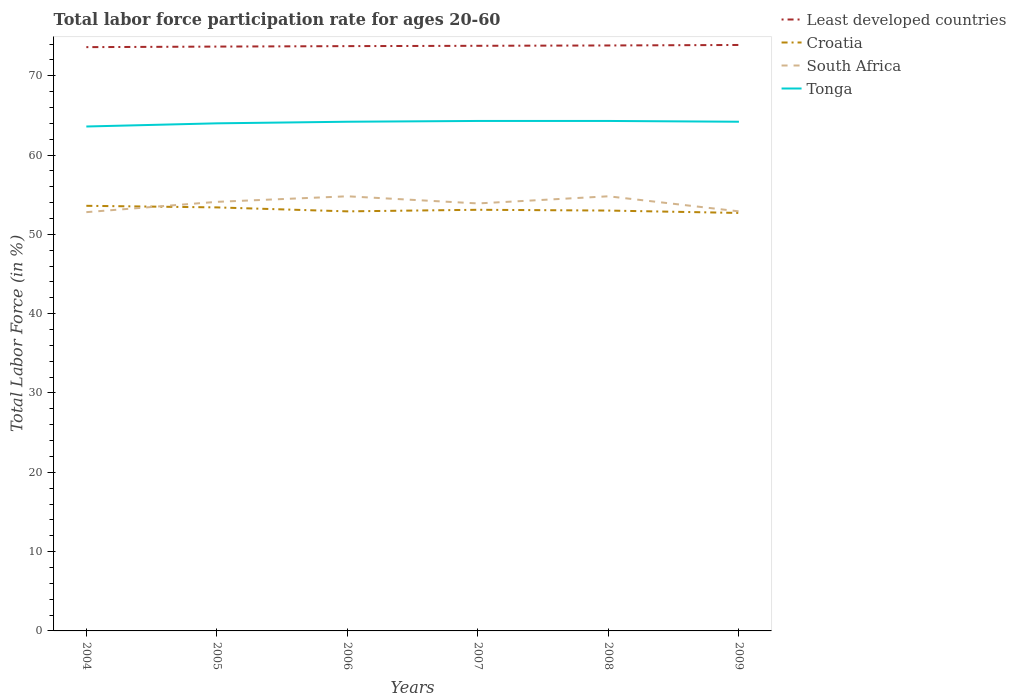How many different coloured lines are there?
Provide a succinct answer. 4. Does the line corresponding to Croatia intersect with the line corresponding to Tonga?
Provide a succinct answer. No. Is the number of lines equal to the number of legend labels?
Keep it short and to the point. Yes. Across all years, what is the maximum labor force participation rate in Croatia?
Ensure brevity in your answer.  52.7. In which year was the labor force participation rate in South Africa maximum?
Offer a very short reply. 2004. What is the total labor force participation rate in Least developed countries in the graph?
Your answer should be very brief. -0.2. What is the difference between the highest and the lowest labor force participation rate in Least developed countries?
Make the answer very short. 3. Is the labor force participation rate in Croatia strictly greater than the labor force participation rate in Least developed countries over the years?
Your response must be concise. Yes. How many lines are there?
Keep it short and to the point. 4. Does the graph contain grids?
Offer a terse response. No. What is the title of the graph?
Make the answer very short. Total labor force participation rate for ages 20-60. Does "Caribbean small states" appear as one of the legend labels in the graph?
Offer a very short reply. No. What is the label or title of the X-axis?
Keep it short and to the point. Years. What is the Total Labor Force (in %) of Least developed countries in 2004?
Give a very brief answer. 73.61. What is the Total Labor Force (in %) of Croatia in 2004?
Provide a short and direct response. 53.6. What is the Total Labor Force (in %) of South Africa in 2004?
Offer a very short reply. 52.8. What is the Total Labor Force (in %) of Tonga in 2004?
Give a very brief answer. 63.6. What is the Total Labor Force (in %) in Least developed countries in 2005?
Offer a terse response. 73.68. What is the Total Labor Force (in %) in Croatia in 2005?
Your response must be concise. 53.4. What is the Total Labor Force (in %) of South Africa in 2005?
Your answer should be compact. 54.1. What is the Total Labor Force (in %) in Least developed countries in 2006?
Your answer should be very brief. 73.73. What is the Total Labor Force (in %) of Croatia in 2006?
Your answer should be compact. 52.9. What is the Total Labor Force (in %) of South Africa in 2006?
Give a very brief answer. 54.8. What is the Total Labor Force (in %) in Tonga in 2006?
Keep it short and to the point. 64.2. What is the Total Labor Force (in %) in Least developed countries in 2007?
Offer a very short reply. 73.77. What is the Total Labor Force (in %) in Croatia in 2007?
Your response must be concise. 53.1. What is the Total Labor Force (in %) in South Africa in 2007?
Your response must be concise. 53.9. What is the Total Labor Force (in %) in Tonga in 2007?
Keep it short and to the point. 64.3. What is the Total Labor Force (in %) of Least developed countries in 2008?
Your answer should be very brief. 73.82. What is the Total Labor Force (in %) in South Africa in 2008?
Your answer should be very brief. 54.8. What is the Total Labor Force (in %) of Tonga in 2008?
Ensure brevity in your answer.  64.3. What is the Total Labor Force (in %) of Least developed countries in 2009?
Keep it short and to the point. 73.88. What is the Total Labor Force (in %) of Croatia in 2009?
Your response must be concise. 52.7. What is the Total Labor Force (in %) of South Africa in 2009?
Offer a terse response. 52.9. What is the Total Labor Force (in %) in Tonga in 2009?
Keep it short and to the point. 64.2. Across all years, what is the maximum Total Labor Force (in %) of Least developed countries?
Your answer should be very brief. 73.88. Across all years, what is the maximum Total Labor Force (in %) in Croatia?
Provide a short and direct response. 53.6. Across all years, what is the maximum Total Labor Force (in %) in South Africa?
Offer a terse response. 54.8. Across all years, what is the maximum Total Labor Force (in %) of Tonga?
Ensure brevity in your answer.  64.3. Across all years, what is the minimum Total Labor Force (in %) of Least developed countries?
Your answer should be very brief. 73.61. Across all years, what is the minimum Total Labor Force (in %) of Croatia?
Provide a succinct answer. 52.7. Across all years, what is the minimum Total Labor Force (in %) in South Africa?
Ensure brevity in your answer.  52.8. Across all years, what is the minimum Total Labor Force (in %) in Tonga?
Offer a very short reply. 63.6. What is the total Total Labor Force (in %) of Least developed countries in the graph?
Offer a terse response. 442.49. What is the total Total Labor Force (in %) of Croatia in the graph?
Ensure brevity in your answer.  318.7. What is the total Total Labor Force (in %) in South Africa in the graph?
Ensure brevity in your answer.  323.3. What is the total Total Labor Force (in %) in Tonga in the graph?
Provide a succinct answer. 384.6. What is the difference between the Total Labor Force (in %) of Least developed countries in 2004 and that in 2005?
Your answer should be very brief. -0.07. What is the difference between the Total Labor Force (in %) in South Africa in 2004 and that in 2005?
Give a very brief answer. -1.3. What is the difference between the Total Labor Force (in %) of Tonga in 2004 and that in 2005?
Give a very brief answer. -0.4. What is the difference between the Total Labor Force (in %) of Least developed countries in 2004 and that in 2006?
Keep it short and to the point. -0.13. What is the difference between the Total Labor Force (in %) of South Africa in 2004 and that in 2006?
Ensure brevity in your answer.  -2. What is the difference between the Total Labor Force (in %) in Tonga in 2004 and that in 2006?
Ensure brevity in your answer.  -0.6. What is the difference between the Total Labor Force (in %) of Least developed countries in 2004 and that in 2007?
Provide a short and direct response. -0.17. What is the difference between the Total Labor Force (in %) in Croatia in 2004 and that in 2007?
Your answer should be very brief. 0.5. What is the difference between the Total Labor Force (in %) of South Africa in 2004 and that in 2007?
Offer a terse response. -1.1. What is the difference between the Total Labor Force (in %) in Least developed countries in 2004 and that in 2008?
Your answer should be very brief. -0.21. What is the difference between the Total Labor Force (in %) in Least developed countries in 2004 and that in 2009?
Your response must be concise. -0.27. What is the difference between the Total Labor Force (in %) in Croatia in 2004 and that in 2009?
Offer a very short reply. 0.9. What is the difference between the Total Labor Force (in %) of South Africa in 2004 and that in 2009?
Provide a succinct answer. -0.1. What is the difference between the Total Labor Force (in %) of Tonga in 2004 and that in 2009?
Provide a succinct answer. -0.6. What is the difference between the Total Labor Force (in %) of Least developed countries in 2005 and that in 2006?
Provide a succinct answer. -0.06. What is the difference between the Total Labor Force (in %) in South Africa in 2005 and that in 2006?
Provide a short and direct response. -0.7. What is the difference between the Total Labor Force (in %) of Tonga in 2005 and that in 2006?
Ensure brevity in your answer.  -0.2. What is the difference between the Total Labor Force (in %) in Least developed countries in 2005 and that in 2007?
Your answer should be very brief. -0.1. What is the difference between the Total Labor Force (in %) in South Africa in 2005 and that in 2007?
Offer a terse response. 0.2. What is the difference between the Total Labor Force (in %) of Tonga in 2005 and that in 2007?
Ensure brevity in your answer.  -0.3. What is the difference between the Total Labor Force (in %) in Least developed countries in 2005 and that in 2008?
Make the answer very short. -0.14. What is the difference between the Total Labor Force (in %) of Croatia in 2005 and that in 2008?
Give a very brief answer. 0.4. What is the difference between the Total Labor Force (in %) in Least developed countries in 2005 and that in 2009?
Ensure brevity in your answer.  -0.2. What is the difference between the Total Labor Force (in %) of Croatia in 2005 and that in 2009?
Your answer should be compact. 0.7. What is the difference between the Total Labor Force (in %) in South Africa in 2005 and that in 2009?
Your answer should be compact. 1.2. What is the difference between the Total Labor Force (in %) in Least developed countries in 2006 and that in 2007?
Give a very brief answer. -0.04. What is the difference between the Total Labor Force (in %) of Tonga in 2006 and that in 2007?
Offer a terse response. -0.1. What is the difference between the Total Labor Force (in %) in Least developed countries in 2006 and that in 2008?
Give a very brief answer. -0.08. What is the difference between the Total Labor Force (in %) of South Africa in 2006 and that in 2008?
Your answer should be very brief. 0. What is the difference between the Total Labor Force (in %) in Tonga in 2006 and that in 2008?
Give a very brief answer. -0.1. What is the difference between the Total Labor Force (in %) in Least developed countries in 2006 and that in 2009?
Your response must be concise. -0.15. What is the difference between the Total Labor Force (in %) of Least developed countries in 2007 and that in 2008?
Your answer should be compact. -0.04. What is the difference between the Total Labor Force (in %) in Croatia in 2007 and that in 2008?
Your answer should be compact. 0.1. What is the difference between the Total Labor Force (in %) of Least developed countries in 2007 and that in 2009?
Ensure brevity in your answer.  -0.1. What is the difference between the Total Labor Force (in %) in Croatia in 2007 and that in 2009?
Keep it short and to the point. 0.4. What is the difference between the Total Labor Force (in %) in South Africa in 2007 and that in 2009?
Keep it short and to the point. 1. What is the difference between the Total Labor Force (in %) of Tonga in 2007 and that in 2009?
Offer a very short reply. 0.1. What is the difference between the Total Labor Force (in %) of Least developed countries in 2008 and that in 2009?
Ensure brevity in your answer.  -0.06. What is the difference between the Total Labor Force (in %) in Croatia in 2008 and that in 2009?
Give a very brief answer. 0.3. What is the difference between the Total Labor Force (in %) of South Africa in 2008 and that in 2009?
Give a very brief answer. 1.9. What is the difference between the Total Labor Force (in %) in Tonga in 2008 and that in 2009?
Your answer should be compact. 0.1. What is the difference between the Total Labor Force (in %) in Least developed countries in 2004 and the Total Labor Force (in %) in Croatia in 2005?
Your answer should be very brief. 20.21. What is the difference between the Total Labor Force (in %) of Least developed countries in 2004 and the Total Labor Force (in %) of South Africa in 2005?
Your answer should be compact. 19.51. What is the difference between the Total Labor Force (in %) of Least developed countries in 2004 and the Total Labor Force (in %) of Tonga in 2005?
Your answer should be very brief. 9.61. What is the difference between the Total Labor Force (in %) of Croatia in 2004 and the Total Labor Force (in %) of Tonga in 2005?
Your response must be concise. -10.4. What is the difference between the Total Labor Force (in %) of South Africa in 2004 and the Total Labor Force (in %) of Tonga in 2005?
Offer a very short reply. -11.2. What is the difference between the Total Labor Force (in %) of Least developed countries in 2004 and the Total Labor Force (in %) of Croatia in 2006?
Your response must be concise. 20.71. What is the difference between the Total Labor Force (in %) of Least developed countries in 2004 and the Total Labor Force (in %) of South Africa in 2006?
Make the answer very short. 18.81. What is the difference between the Total Labor Force (in %) in Least developed countries in 2004 and the Total Labor Force (in %) in Tonga in 2006?
Give a very brief answer. 9.41. What is the difference between the Total Labor Force (in %) in Croatia in 2004 and the Total Labor Force (in %) in Tonga in 2006?
Give a very brief answer. -10.6. What is the difference between the Total Labor Force (in %) in Least developed countries in 2004 and the Total Labor Force (in %) in Croatia in 2007?
Offer a very short reply. 20.51. What is the difference between the Total Labor Force (in %) of Least developed countries in 2004 and the Total Labor Force (in %) of South Africa in 2007?
Provide a short and direct response. 19.71. What is the difference between the Total Labor Force (in %) in Least developed countries in 2004 and the Total Labor Force (in %) in Tonga in 2007?
Give a very brief answer. 9.31. What is the difference between the Total Labor Force (in %) in Croatia in 2004 and the Total Labor Force (in %) in South Africa in 2007?
Give a very brief answer. -0.3. What is the difference between the Total Labor Force (in %) in Croatia in 2004 and the Total Labor Force (in %) in Tonga in 2007?
Give a very brief answer. -10.7. What is the difference between the Total Labor Force (in %) in Least developed countries in 2004 and the Total Labor Force (in %) in Croatia in 2008?
Your response must be concise. 20.61. What is the difference between the Total Labor Force (in %) of Least developed countries in 2004 and the Total Labor Force (in %) of South Africa in 2008?
Your response must be concise. 18.81. What is the difference between the Total Labor Force (in %) in Least developed countries in 2004 and the Total Labor Force (in %) in Tonga in 2008?
Ensure brevity in your answer.  9.31. What is the difference between the Total Labor Force (in %) of Croatia in 2004 and the Total Labor Force (in %) of South Africa in 2008?
Ensure brevity in your answer.  -1.2. What is the difference between the Total Labor Force (in %) in Croatia in 2004 and the Total Labor Force (in %) in Tonga in 2008?
Your response must be concise. -10.7. What is the difference between the Total Labor Force (in %) in Least developed countries in 2004 and the Total Labor Force (in %) in Croatia in 2009?
Provide a succinct answer. 20.91. What is the difference between the Total Labor Force (in %) in Least developed countries in 2004 and the Total Labor Force (in %) in South Africa in 2009?
Your response must be concise. 20.71. What is the difference between the Total Labor Force (in %) of Least developed countries in 2004 and the Total Labor Force (in %) of Tonga in 2009?
Keep it short and to the point. 9.41. What is the difference between the Total Labor Force (in %) in Croatia in 2004 and the Total Labor Force (in %) in South Africa in 2009?
Your answer should be compact. 0.7. What is the difference between the Total Labor Force (in %) in South Africa in 2004 and the Total Labor Force (in %) in Tonga in 2009?
Offer a very short reply. -11.4. What is the difference between the Total Labor Force (in %) in Least developed countries in 2005 and the Total Labor Force (in %) in Croatia in 2006?
Your answer should be very brief. 20.78. What is the difference between the Total Labor Force (in %) of Least developed countries in 2005 and the Total Labor Force (in %) of South Africa in 2006?
Your answer should be very brief. 18.88. What is the difference between the Total Labor Force (in %) in Least developed countries in 2005 and the Total Labor Force (in %) in Tonga in 2006?
Offer a terse response. 9.48. What is the difference between the Total Labor Force (in %) in Croatia in 2005 and the Total Labor Force (in %) in South Africa in 2006?
Provide a succinct answer. -1.4. What is the difference between the Total Labor Force (in %) of Croatia in 2005 and the Total Labor Force (in %) of Tonga in 2006?
Your response must be concise. -10.8. What is the difference between the Total Labor Force (in %) of South Africa in 2005 and the Total Labor Force (in %) of Tonga in 2006?
Your response must be concise. -10.1. What is the difference between the Total Labor Force (in %) of Least developed countries in 2005 and the Total Labor Force (in %) of Croatia in 2007?
Ensure brevity in your answer.  20.58. What is the difference between the Total Labor Force (in %) in Least developed countries in 2005 and the Total Labor Force (in %) in South Africa in 2007?
Provide a succinct answer. 19.78. What is the difference between the Total Labor Force (in %) of Least developed countries in 2005 and the Total Labor Force (in %) of Tonga in 2007?
Offer a terse response. 9.38. What is the difference between the Total Labor Force (in %) in Croatia in 2005 and the Total Labor Force (in %) in Tonga in 2007?
Your response must be concise. -10.9. What is the difference between the Total Labor Force (in %) of South Africa in 2005 and the Total Labor Force (in %) of Tonga in 2007?
Provide a succinct answer. -10.2. What is the difference between the Total Labor Force (in %) in Least developed countries in 2005 and the Total Labor Force (in %) in Croatia in 2008?
Offer a terse response. 20.68. What is the difference between the Total Labor Force (in %) in Least developed countries in 2005 and the Total Labor Force (in %) in South Africa in 2008?
Offer a very short reply. 18.88. What is the difference between the Total Labor Force (in %) in Least developed countries in 2005 and the Total Labor Force (in %) in Tonga in 2008?
Your answer should be compact. 9.38. What is the difference between the Total Labor Force (in %) in Croatia in 2005 and the Total Labor Force (in %) in South Africa in 2008?
Offer a terse response. -1.4. What is the difference between the Total Labor Force (in %) of Croatia in 2005 and the Total Labor Force (in %) of Tonga in 2008?
Offer a terse response. -10.9. What is the difference between the Total Labor Force (in %) of South Africa in 2005 and the Total Labor Force (in %) of Tonga in 2008?
Provide a short and direct response. -10.2. What is the difference between the Total Labor Force (in %) in Least developed countries in 2005 and the Total Labor Force (in %) in Croatia in 2009?
Make the answer very short. 20.98. What is the difference between the Total Labor Force (in %) of Least developed countries in 2005 and the Total Labor Force (in %) of South Africa in 2009?
Your answer should be compact. 20.78. What is the difference between the Total Labor Force (in %) in Least developed countries in 2005 and the Total Labor Force (in %) in Tonga in 2009?
Provide a succinct answer. 9.48. What is the difference between the Total Labor Force (in %) of Least developed countries in 2006 and the Total Labor Force (in %) of Croatia in 2007?
Provide a succinct answer. 20.63. What is the difference between the Total Labor Force (in %) of Least developed countries in 2006 and the Total Labor Force (in %) of South Africa in 2007?
Provide a short and direct response. 19.83. What is the difference between the Total Labor Force (in %) of Least developed countries in 2006 and the Total Labor Force (in %) of Tonga in 2007?
Your answer should be compact. 9.43. What is the difference between the Total Labor Force (in %) of Croatia in 2006 and the Total Labor Force (in %) of Tonga in 2007?
Keep it short and to the point. -11.4. What is the difference between the Total Labor Force (in %) in Least developed countries in 2006 and the Total Labor Force (in %) in Croatia in 2008?
Offer a very short reply. 20.73. What is the difference between the Total Labor Force (in %) in Least developed countries in 2006 and the Total Labor Force (in %) in South Africa in 2008?
Provide a succinct answer. 18.93. What is the difference between the Total Labor Force (in %) in Least developed countries in 2006 and the Total Labor Force (in %) in Tonga in 2008?
Provide a short and direct response. 9.43. What is the difference between the Total Labor Force (in %) in South Africa in 2006 and the Total Labor Force (in %) in Tonga in 2008?
Offer a very short reply. -9.5. What is the difference between the Total Labor Force (in %) of Least developed countries in 2006 and the Total Labor Force (in %) of Croatia in 2009?
Offer a very short reply. 21.03. What is the difference between the Total Labor Force (in %) of Least developed countries in 2006 and the Total Labor Force (in %) of South Africa in 2009?
Your response must be concise. 20.83. What is the difference between the Total Labor Force (in %) in Least developed countries in 2006 and the Total Labor Force (in %) in Tonga in 2009?
Offer a very short reply. 9.53. What is the difference between the Total Labor Force (in %) in Croatia in 2006 and the Total Labor Force (in %) in Tonga in 2009?
Your answer should be very brief. -11.3. What is the difference between the Total Labor Force (in %) of South Africa in 2006 and the Total Labor Force (in %) of Tonga in 2009?
Ensure brevity in your answer.  -9.4. What is the difference between the Total Labor Force (in %) of Least developed countries in 2007 and the Total Labor Force (in %) of Croatia in 2008?
Ensure brevity in your answer.  20.77. What is the difference between the Total Labor Force (in %) of Least developed countries in 2007 and the Total Labor Force (in %) of South Africa in 2008?
Keep it short and to the point. 18.97. What is the difference between the Total Labor Force (in %) in Least developed countries in 2007 and the Total Labor Force (in %) in Tonga in 2008?
Provide a succinct answer. 9.47. What is the difference between the Total Labor Force (in %) in Croatia in 2007 and the Total Labor Force (in %) in South Africa in 2008?
Keep it short and to the point. -1.7. What is the difference between the Total Labor Force (in %) of South Africa in 2007 and the Total Labor Force (in %) of Tonga in 2008?
Your answer should be compact. -10.4. What is the difference between the Total Labor Force (in %) in Least developed countries in 2007 and the Total Labor Force (in %) in Croatia in 2009?
Offer a terse response. 21.07. What is the difference between the Total Labor Force (in %) in Least developed countries in 2007 and the Total Labor Force (in %) in South Africa in 2009?
Your answer should be compact. 20.87. What is the difference between the Total Labor Force (in %) in Least developed countries in 2007 and the Total Labor Force (in %) in Tonga in 2009?
Provide a succinct answer. 9.57. What is the difference between the Total Labor Force (in %) of Croatia in 2007 and the Total Labor Force (in %) of South Africa in 2009?
Your response must be concise. 0.2. What is the difference between the Total Labor Force (in %) of Croatia in 2007 and the Total Labor Force (in %) of Tonga in 2009?
Your answer should be very brief. -11.1. What is the difference between the Total Labor Force (in %) in South Africa in 2007 and the Total Labor Force (in %) in Tonga in 2009?
Make the answer very short. -10.3. What is the difference between the Total Labor Force (in %) in Least developed countries in 2008 and the Total Labor Force (in %) in Croatia in 2009?
Provide a short and direct response. 21.12. What is the difference between the Total Labor Force (in %) in Least developed countries in 2008 and the Total Labor Force (in %) in South Africa in 2009?
Make the answer very short. 20.92. What is the difference between the Total Labor Force (in %) of Least developed countries in 2008 and the Total Labor Force (in %) of Tonga in 2009?
Make the answer very short. 9.62. What is the difference between the Total Labor Force (in %) in South Africa in 2008 and the Total Labor Force (in %) in Tonga in 2009?
Provide a succinct answer. -9.4. What is the average Total Labor Force (in %) in Least developed countries per year?
Ensure brevity in your answer.  73.75. What is the average Total Labor Force (in %) of Croatia per year?
Provide a succinct answer. 53.12. What is the average Total Labor Force (in %) of South Africa per year?
Provide a succinct answer. 53.88. What is the average Total Labor Force (in %) of Tonga per year?
Your answer should be compact. 64.1. In the year 2004, what is the difference between the Total Labor Force (in %) of Least developed countries and Total Labor Force (in %) of Croatia?
Your answer should be very brief. 20.01. In the year 2004, what is the difference between the Total Labor Force (in %) of Least developed countries and Total Labor Force (in %) of South Africa?
Your answer should be compact. 20.81. In the year 2004, what is the difference between the Total Labor Force (in %) in Least developed countries and Total Labor Force (in %) in Tonga?
Give a very brief answer. 10.01. In the year 2004, what is the difference between the Total Labor Force (in %) in Croatia and Total Labor Force (in %) in Tonga?
Make the answer very short. -10. In the year 2005, what is the difference between the Total Labor Force (in %) of Least developed countries and Total Labor Force (in %) of Croatia?
Your answer should be very brief. 20.28. In the year 2005, what is the difference between the Total Labor Force (in %) of Least developed countries and Total Labor Force (in %) of South Africa?
Provide a short and direct response. 19.58. In the year 2005, what is the difference between the Total Labor Force (in %) of Least developed countries and Total Labor Force (in %) of Tonga?
Your response must be concise. 9.68. In the year 2005, what is the difference between the Total Labor Force (in %) of Croatia and Total Labor Force (in %) of South Africa?
Your response must be concise. -0.7. In the year 2005, what is the difference between the Total Labor Force (in %) in South Africa and Total Labor Force (in %) in Tonga?
Provide a short and direct response. -9.9. In the year 2006, what is the difference between the Total Labor Force (in %) of Least developed countries and Total Labor Force (in %) of Croatia?
Offer a very short reply. 20.83. In the year 2006, what is the difference between the Total Labor Force (in %) in Least developed countries and Total Labor Force (in %) in South Africa?
Provide a succinct answer. 18.93. In the year 2006, what is the difference between the Total Labor Force (in %) in Least developed countries and Total Labor Force (in %) in Tonga?
Your answer should be very brief. 9.53. In the year 2006, what is the difference between the Total Labor Force (in %) of South Africa and Total Labor Force (in %) of Tonga?
Ensure brevity in your answer.  -9.4. In the year 2007, what is the difference between the Total Labor Force (in %) in Least developed countries and Total Labor Force (in %) in Croatia?
Make the answer very short. 20.67. In the year 2007, what is the difference between the Total Labor Force (in %) of Least developed countries and Total Labor Force (in %) of South Africa?
Your response must be concise. 19.87. In the year 2007, what is the difference between the Total Labor Force (in %) of Least developed countries and Total Labor Force (in %) of Tonga?
Your answer should be very brief. 9.47. In the year 2007, what is the difference between the Total Labor Force (in %) in Croatia and Total Labor Force (in %) in South Africa?
Ensure brevity in your answer.  -0.8. In the year 2008, what is the difference between the Total Labor Force (in %) in Least developed countries and Total Labor Force (in %) in Croatia?
Offer a terse response. 20.82. In the year 2008, what is the difference between the Total Labor Force (in %) in Least developed countries and Total Labor Force (in %) in South Africa?
Your response must be concise. 19.02. In the year 2008, what is the difference between the Total Labor Force (in %) of Least developed countries and Total Labor Force (in %) of Tonga?
Offer a terse response. 9.52. In the year 2008, what is the difference between the Total Labor Force (in %) in South Africa and Total Labor Force (in %) in Tonga?
Your response must be concise. -9.5. In the year 2009, what is the difference between the Total Labor Force (in %) of Least developed countries and Total Labor Force (in %) of Croatia?
Your answer should be very brief. 21.18. In the year 2009, what is the difference between the Total Labor Force (in %) of Least developed countries and Total Labor Force (in %) of South Africa?
Your answer should be compact. 20.98. In the year 2009, what is the difference between the Total Labor Force (in %) of Least developed countries and Total Labor Force (in %) of Tonga?
Your response must be concise. 9.68. In the year 2009, what is the difference between the Total Labor Force (in %) of Croatia and Total Labor Force (in %) of South Africa?
Ensure brevity in your answer.  -0.2. What is the ratio of the Total Labor Force (in %) of Least developed countries in 2004 to that in 2005?
Provide a succinct answer. 1. What is the ratio of the Total Labor Force (in %) of Croatia in 2004 to that in 2005?
Provide a succinct answer. 1. What is the ratio of the Total Labor Force (in %) of South Africa in 2004 to that in 2005?
Your answer should be very brief. 0.98. What is the ratio of the Total Labor Force (in %) of Croatia in 2004 to that in 2006?
Offer a very short reply. 1.01. What is the ratio of the Total Labor Force (in %) in South Africa in 2004 to that in 2006?
Your answer should be compact. 0.96. What is the ratio of the Total Labor Force (in %) in Least developed countries in 2004 to that in 2007?
Provide a succinct answer. 1. What is the ratio of the Total Labor Force (in %) of Croatia in 2004 to that in 2007?
Give a very brief answer. 1.01. What is the ratio of the Total Labor Force (in %) of South Africa in 2004 to that in 2007?
Provide a succinct answer. 0.98. What is the ratio of the Total Labor Force (in %) in Tonga in 2004 to that in 2007?
Keep it short and to the point. 0.99. What is the ratio of the Total Labor Force (in %) in Least developed countries in 2004 to that in 2008?
Provide a short and direct response. 1. What is the ratio of the Total Labor Force (in %) in Croatia in 2004 to that in 2008?
Your answer should be very brief. 1.01. What is the ratio of the Total Labor Force (in %) in South Africa in 2004 to that in 2008?
Provide a succinct answer. 0.96. What is the ratio of the Total Labor Force (in %) in Croatia in 2004 to that in 2009?
Provide a short and direct response. 1.02. What is the ratio of the Total Labor Force (in %) in Croatia in 2005 to that in 2006?
Your answer should be compact. 1.01. What is the ratio of the Total Labor Force (in %) of South Africa in 2005 to that in 2006?
Offer a terse response. 0.99. What is the ratio of the Total Labor Force (in %) in Croatia in 2005 to that in 2007?
Provide a succinct answer. 1.01. What is the ratio of the Total Labor Force (in %) in Least developed countries in 2005 to that in 2008?
Make the answer very short. 1. What is the ratio of the Total Labor Force (in %) of Croatia in 2005 to that in 2008?
Your answer should be compact. 1.01. What is the ratio of the Total Labor Force (in %) in South Africa in 2005 to that in 2008?
Give a very brief answer. 0.99. What is the ratio of the Total Labor Force (in %) of Croatia in 2005 to that in 2009?
Offer a terse response. 1.01. What is the ratio of the Total Labor Force (in %) of South Africa in 2005 to that in 2009?
Your answer should be compact. 1.02. What is the ratio of the Total Labor Force (in %) of Tonga in 2005 to that in 2009?
Ensure brevity in your answer.  1. What is the ratio of the Total Labor Force (in %) of Least developed countries in 2006 to that in 2007?
Make the answer very short. 1. What is the ratio of the Total Labor Force (in %) in South Africa in 2006 to that in 2007?
Your answer should be very brief. 1.02. What is the ratio of the Total Labor Force (in %) in Least developed countries in 2006 to that in 2009?
Your response must be concise. 1. What is the ratio of the Total Labor Force (in %) of South Africa in 2006 to that in 2009?
Offer a terse response. 1.04. What is the ratio of the Total Labor Force (in %) of Tonga in 2006 to that in 2009?
Your response must be concise. 1. What is the ratio of the Total Labor Force (in %) of Least developed countries in 2007 to that in 2008?
Keep it short and to the point. 1. What is the ratio of the Total Labor Force (in %) of Croatia in 2007 to that in 2008?
Your answer should be compact. 1. What is the ratio of the Total Labor Force (in %) in South Africa in 2007 to that in 2008?
Your response must be concise. 0.98. What is the ratio of the Total Labor Force (in %) in Tonga in 2007 to that in 2008?
Make the answer very short. 1. What is the ratio of the Total Labor Force (in %) in Croatia in 2007 to that in 2009?
Give a very brief answer. 1.01. What is the ratio of the Total Labor Force (in %) in South Africa in 2007 to that in 2009?
Offer a terse response. 1.02. What is the ratio of the Total Labor Force (in %) in Tonga in 2007 to that in 2009?
Your answer should be compact. 1. What is the ratio of the Total Labor Force (in %) of Least developed countries in 2008 to that in 2009?
Offer a terse response. 1. What is the ratio of the Total Labor Force (in %) of South Africa in 2008 to that in 2009?
Your answer should be compact. 1.04. What is the ratio of the Total Labor Force (in %) in Tonga in 2008 to that in 2009?
Offer a terse response. 1. What is the difference between the highest and the second highest Total Labor Force (in %) in Least developed countries?
Provide a short and direct response. 0.06. What is the difference between the highest and the second highest Total Labor Force (in %) in South Africa?
Offer a terse response. 0. What is the difference between the highest and the lowest Total Labor Force (in %) of Least developed countries?
Offer a very short reply. 0.27. What is the difference between the highest and the lowest Total Labor Force (in %) of Croatia?
Provide a short and direct response. 0.9. What is the difference between the highest and the lowest Total Labor Force (in %) in Tonga?
Your answer should be very brief. 0.7. 